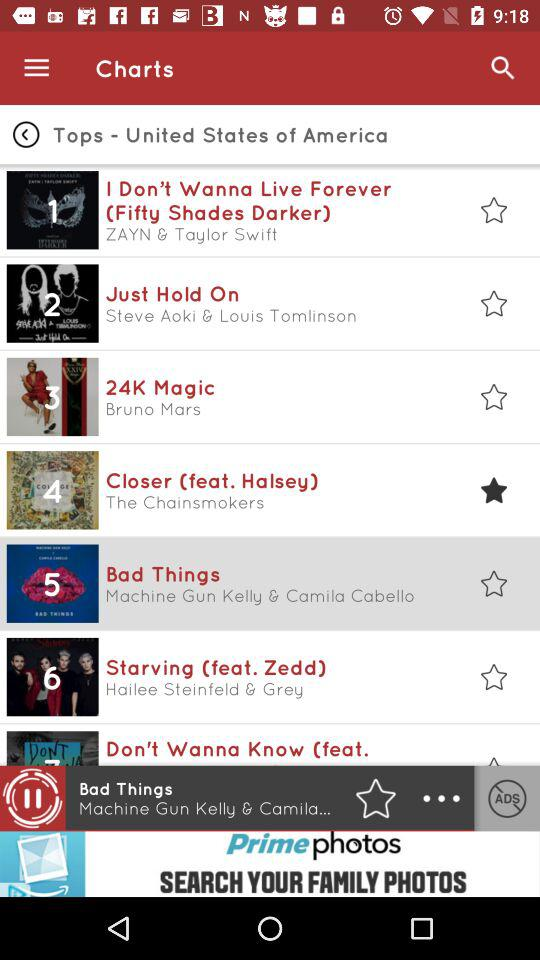Which song is playing? It is "Bad Things". 